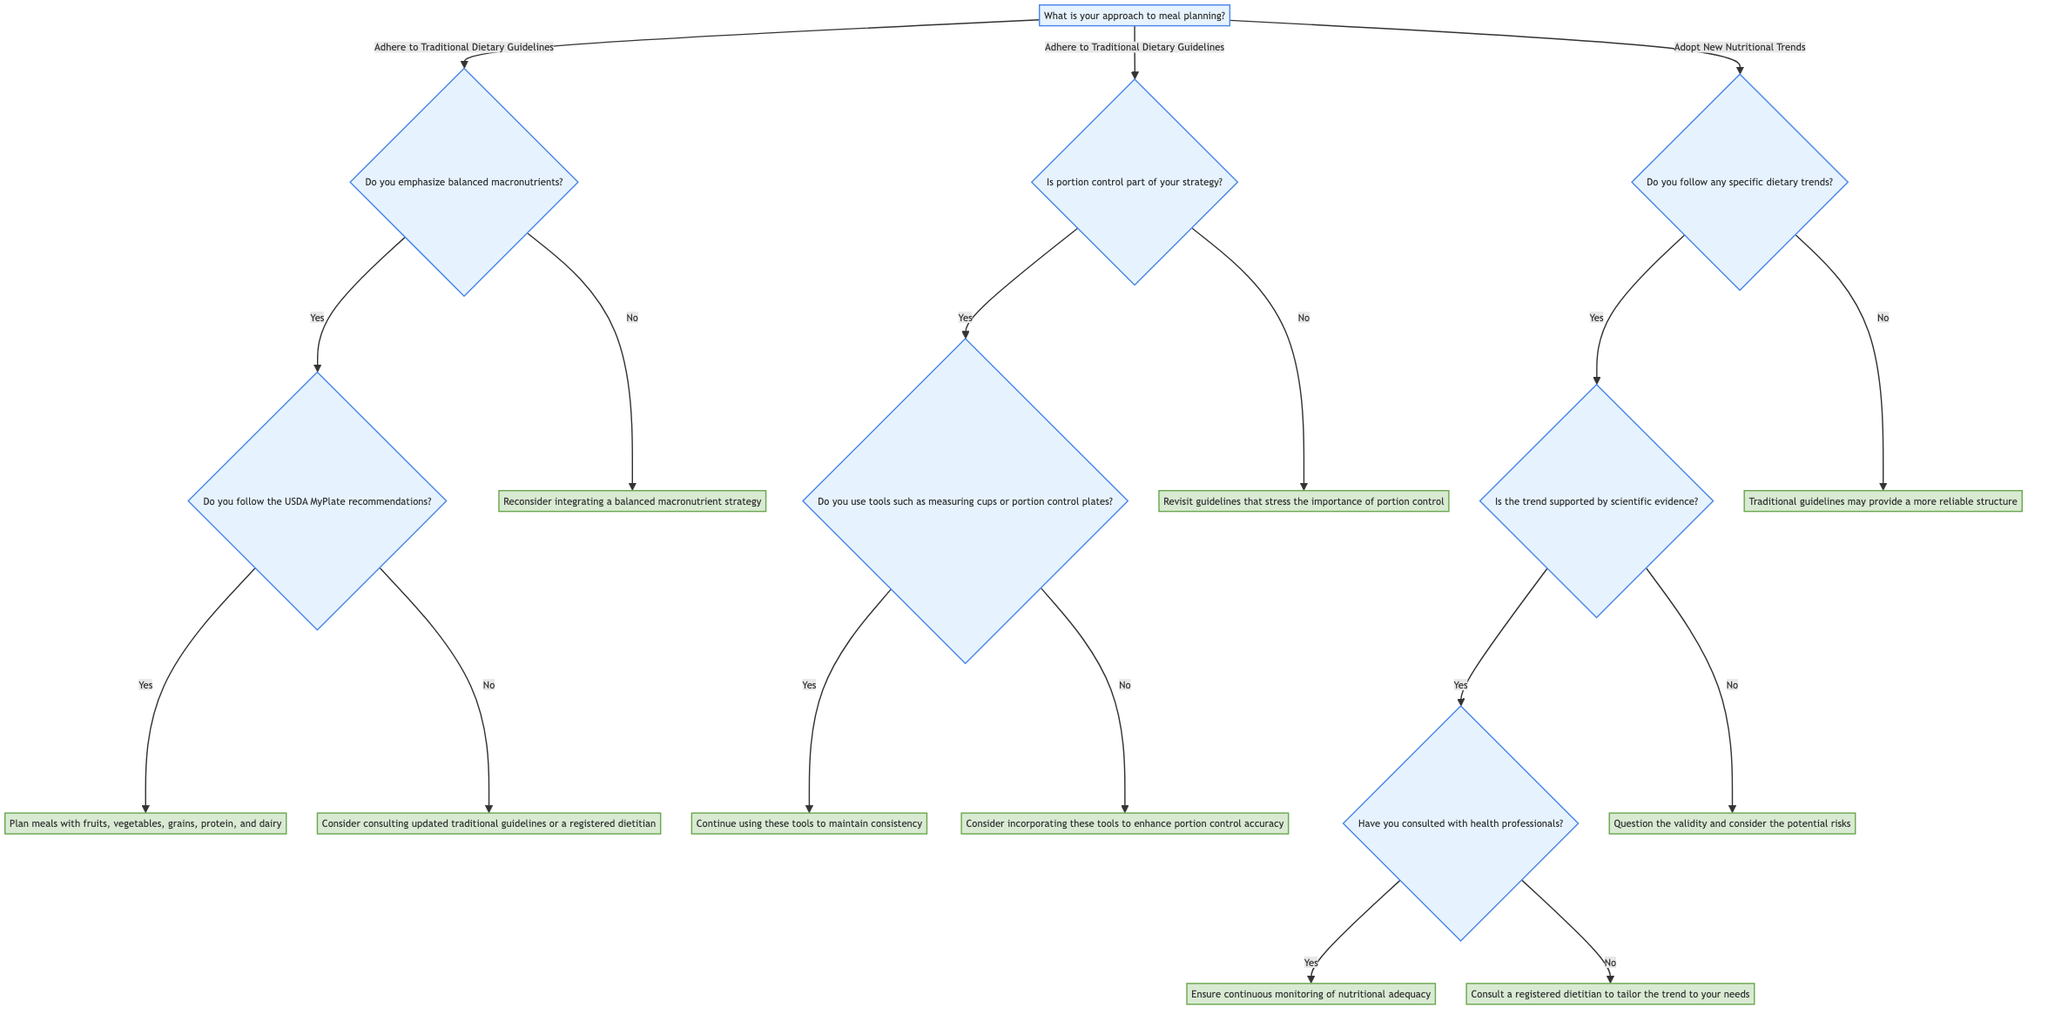What is the first question asked in the decision tree? The first question is labeled "What is your approach to meal planning?" which starts the flow of the decision-making process in the tree.
Answer: What is your approach to meal planning? How many options are available after the first question? After the first question, there are two options presented: "Adhere to Traditional Dietary Guidelines" and "Adopt New Nutritional Trends."
Answer: 2 What is the outcome if someone does not emphasize balanced macronutrients? If the response to "Do you emphasize balanced macronutrients?" is "No," the outcome is "Reconsider integrating a balanced macronutrient strategy to align with traditional guidelines."
Answer: Reconsider integrating a balanced macronutrient strategy to align with traditional guidelines What follows if someone chooses the "Yes" option for consulting health professionals? If someone has consulted with health professionals, the next outcome is "Ensure continuous monitoring of nutritional adequacy," following the reasoning through the options related to dietary trends.
Answer: Ensure continuous monitoring of nutritional adequacy What is the result of choosing "No" for the question about following the USDA MyPlate recommendations? Choosing "No" for this question leads to the outcome "Consider consulting updated traditional guidelines or a registered dietitian." This shows the importance of seeking guidance when not following established recommendations.
Answer: Consider consulting updated traditional guidelines or a registered dietitian What two outcomes are possible if the trend is not supported by scientific evidence? If the dietary trend is not supported by scientific evidence, the outcome is "Question the validity and consider the potential risks before adoption.” This indicates potential caution when evaluating new trends.
Answer: Question the validity and consider the potential risks before adoption What is the importance of using tools like measuring cups in meal planning? The importance of using measuring cups and portion control plates is emphasized when the answer to "Do you use tools such as measuring cups or portion control plates?" is "No," leading to the suggestion: "Consider incorporating these tools to enhance portion control accuracy."
Answer: Consider incorporating these tools to enhance portion control accuracy What decision follows if the answer to whether the trend is scientifically supported is "Yes"? If the trend is scientifically supported (answer "Yes"), the next question is "Have you consulted with health professionals?" leading to further guidance based on professional consultation.
Answer: Have you consulted with health professionals? 